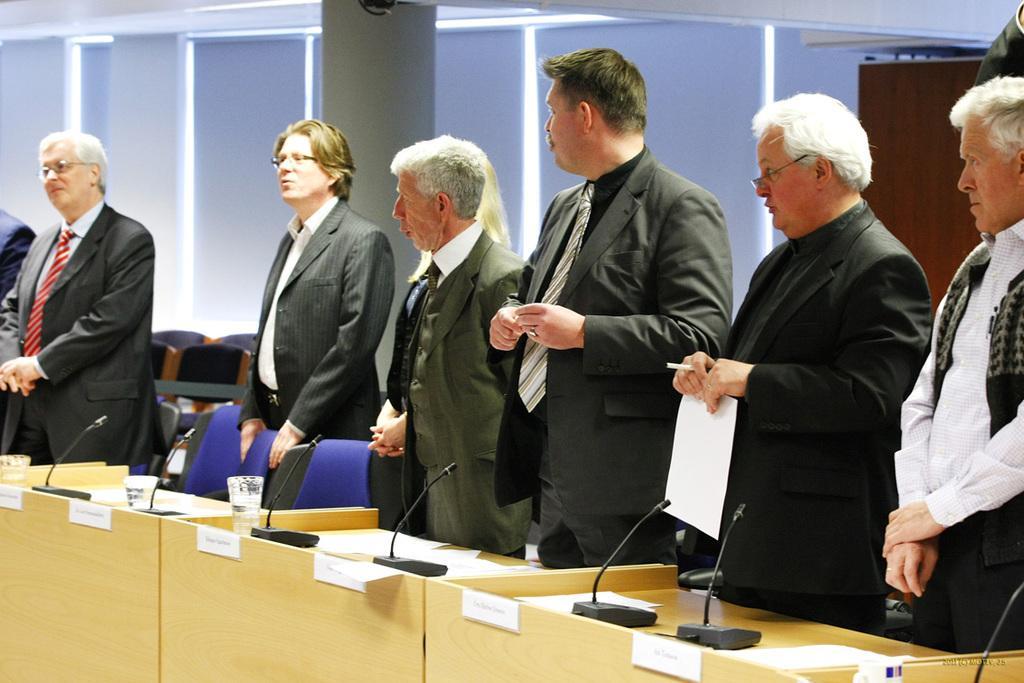Can you describe this image briefly? In this picture we can see a group of people wore blazers, ties and standing and in front of them we can see mics, glasses,chairs and in the background we can see pillars, wall. 